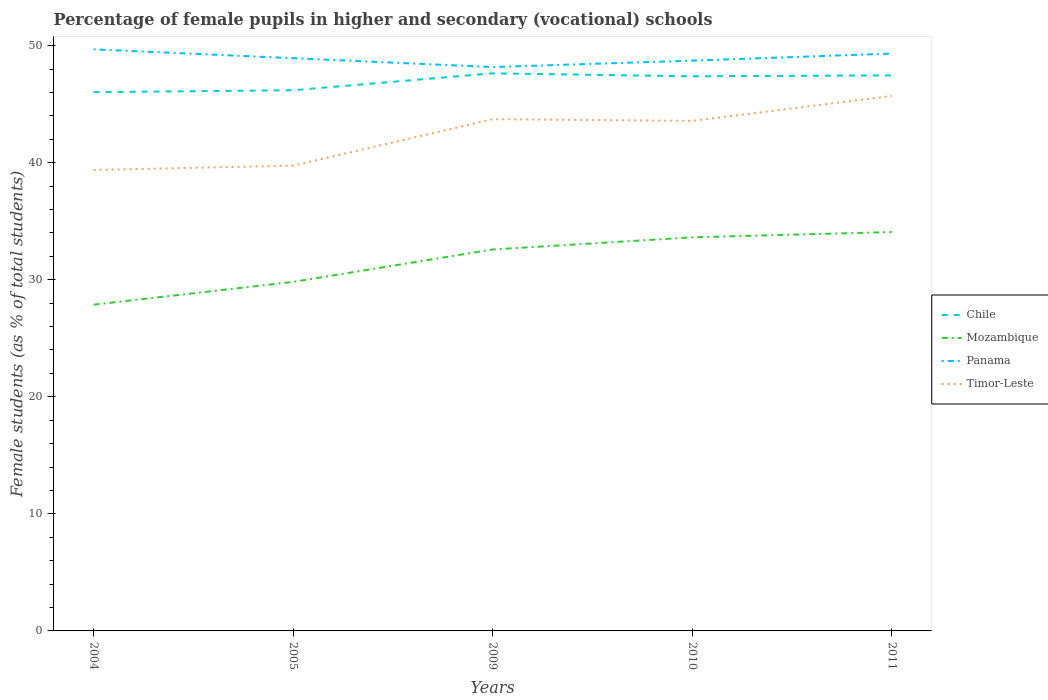How many different coloured lines are there?
Your answer should be compact. 4. Does the line corresponding to Timor-Leste intersect with the line corresponding to Chile?
Provide a short and direct response. No. Is the number of lines equal to the number of legend labels?
Ensure brevity in your answer.  Yes. Across all years, what is the maximum percentage of female pupils in higher and secondary schools in Mozambique?
Provide a succinct answer. 27.87. In which year was the percentage of female pupils in higher and secondary schools in Timor-Leste maximum?
Your answer should be very brief. 2004. What is the total percentage of female pupils in higher and secondary schools in Timor-Leste in the graph?
Keep it short and to the point. 0.15. What is the difference between the highest and the second highest percentage of female pupils in higher and secondary schools in Chile?
Provide a short and direct response. 1.61. What is the difference between the highest and the lowest percentage of female pupils in higher and secondary schools in Timor-Leste?
Provide a short and direct response. 3. Is the percentage of female pupils in higher and secondary schools in Chile strictly greater than the percentage of female pupils in higher and secondary schools in Panama over the years?
Keep it short and to the point. Yes. How many lines are there?
Ensure brevity in your answer.  4. What is the difference between two consecutive major ticks on the Y-axis?
Offer a terse response. 10. How many legend labels are there?
Your answer should be very brief. 4. How are the legend labels stacked?
Provide a succinct answer. Vertical. What is the title of the graph?
Offer a very short reply. Percentage of female pupils in higher and secondary (vocational) schools. What is the label or title of the X-axis?
Give a very brief answer. Years. What is the label or title of the Y-axis?
Your answer should be very brief. Female students (as % of total students). What is the Female students (as % of total students) in Chile in 2004?
Your answer should be compact. 46.03. What is the Female students (as % of total students) of Mozambique in 2004?
Your answer should be very brief. 27.87. What is the Female students (as % of total students) in Panama in 2004?
Your answer should be compact. 49.68. What is the Female students (as % of total students) of Timor-Leste in 2004?
Offer a very short reply. 39.38. What is the Female students (as % of total students) of Chile in 2005?
Keep it short and to the point. 46.19. What is the Female students (as % of total students) of Mozambique in 2005?
Your answer should be very brief. 29.82. What is the Female students (as % of total students) of Panama in 2005?
Provide a succinct answer. 48.93. What is the Female students (as % of total students) in Timor-Leste in 2005?
Your response must be concise. 39.75. What is the Female students (as % of total students) in Chile in 2009?
Your answer should be compact. 47.64. What is the Female students (as % of total students) in Mozambique in 2009?
Ensure brevity in your answer.  32.59. What is the Female students (as % of total students) of Panama in 2009?
Offer a very short reply. 48.17. What is the Female students (as % of total students) in Timor-Leste in 2009?
Your answer should be very brief. 43.72. What is the Female students (as % of total students) in Chile in 2010?
Make the answer very short. 47.38. What is the Female students (as % of total students) in Mozambique in 2010?
Provide a short and direct response. 33.62. What is the Female students (as % of total students) of Panama in 2010?
Offer a terse response. 48.72. What is the Female students (as % of total students) of Timor-Leste in 2010?
Your answer should be very brief. 43.57. What is the Female students (as % of total students) of Chile in 2011?
Ensure brevity in your answer.  47.46. What is the Female students (as % of total students) in Mozambique in 2011?
Offer a terse response. 34.08. What is the Female students (as % of total students) in Panama in 2011?
Your answer should be compact. 49.33. What is the Female students (as % of total students) in Timor-Leste in 2011?
Provide a short and direct response. 45.71. Across all years, what is the maximum Female students (as % of total students) in Chile?
Provide a short and direct response. 47.64. Across all years, what is the maximum Female students (as % of total students) in Mozambique?
Offer a very short reply. 34.08. Across all years, what is the maximum Female students (as % of total students) of Panama?
Your response must be concise. 49.68. Across all years, what is the maximum Female students (as % of total students) of Timor-Leste?
Your answer should be compact. 45.71. Across all years, what is the minimum Female students (as % of total students) in Chile?
Keep it short and to the point. 46.03. Across all years, what is the minimum Female students (as % of total students) of Mozambique?
Provide a succinct answer. 27.87. Across all years, what is the minimum Female students (as % of total students) in Panama?
Ensure brevity in your answer.  48.17. Across all years, what is the minimum Female students (as % of total students) in Timor-Leste?
Make the answer very short. 39.38. What is the total Female students (as % of total students) of Chile in the graph?
Keep it short and to the point. 234.7. What is the total Female students (as % of total students) of Mozambique in the graph?
Provide a succinct answer. 157.98. What is the total Female students (as % of total students) in Panama in the graph?
Offer a very short reply. 244.83. What is the total Female students (as % of total students) of Timor-Leste in the graph?
Offer a very short reply. 212.13. What is the difference between the Female students (as % of total students) of Chile in 2004 and that in 2005?
Your response must be concise. -0.17. What is the difference between the Female students (as % of total students) of Mozambique in 2004 and that in 2005?
Keep it short and to the point. -1.94. What is the difference between the Female students (as % of total students) in Panama in 2004 and that in 2005?
Keep it short and to the point. 0.76. What is the difference between the Female students (as % of total students) in Timor-Leste in 2004 and that in 2005?
Provide a succinct answer. -0.37. What is the difference between the Female students (as % of total students) of Chile in 2004 and that in 2009?
Ensure brevity in your answer.  -1.61. What is the difference between the Female students (as % of total students) of Mozambique in 2004 and that in 2009?
Your answer should be very brief. -4.71. What is the difference between the Female students (as % of total students) of Panama in 2004 and that in 2009?
Your answer should be very brief. 1.51. What is the difference between the Female students (as % of total students) in Timor-Leste in 2004 and that in 2009?
Provide a short and direct response. -4.34. What is the difference between the Female students (as % of total students) in Chile in 2004 and that in 2010?
Your answer should be compact. -1.35. What is the difference between the Female students (as % of total students) of Mozambique in 2004 and that in 2010?
Offer a very short reply. -5.75. What is the difference between the Female students (as % of total students) of Panama in 2004 and that in 2010?
Your response must be concise. 0.96. What is the difference between the Female students (as % of total students) in Timor-Leste in 2004 and that in 2010?
Keep it short and to the point. -4.2. What is the difference between the Female students (as % of total students) in Chile in 2004 and that in 2011?
Provide a succinct answer. -1.44. What is the difference between the Female students (as % of total students) of Mozambique in 2004 and that in 2011?
Your answer should be very brief. -6.2. What is the difference between the Female students (as % of total students) of Panama in 2004 and that in 2011?
Your answer should be very brief. 0.36. What is the difference between the Female students (as % of total students) of Timor-Leste in 2004 and that in 2011?
Ensure brevity in your answer.  -6.33. What is the difference between the Female students (as % of total students) of Chile in 2005 and that in 2009?
Your answer should be compact. -1.44. What is the difference between the Female students (as % of total students) of Mozambique in 2005 and that in 2009?
Offer a terse response. -2.77. What is the difference between the Female students (as % of total students) in Panama in 2005 and that in 2009?
Make the answer very short. 0.76. What is the difference between the Female students (as % of total students) of Timor-Leste in 2005 and that in 2009?
Give a very brief answer. -3.97. What is the difference between the Female students (as % of total students) of Chile in 2005 and that in 2010?
Offer a terse response. -1.19. What is the difference between the Female students (as % of total students) in Mozambique in 2005 and that in 2010?
Your response must be concise. -3.81. What is the difference between the Female students (as % of total students) of Panama in 2005 and that in 2010?
Your answer should be compact. 0.21. What is the difference between the Female students (as % of total students) in Timor-Leste in 2005 and that in 2010?
Your answer should be very brief. -3.82. What is the difference between the Female students (as % of total students) of Chile in 2005 and that in 2011?
Offer a very short reply. -1.27. What is the difference between the Female students (as % of total students) in Mozambique in 2005 and that in 2011?
Keep it short and to the point. -4.26. What is the difference between the Female students (as % of total students) of Panama in 2005 and that in 2011?
Offer a very short reply. -0.4. What is the difference between the Female students (as % of total students) in Timor-Leste in 2005 and that in 2011?
Keep it short and to the point. -5.96. What is the difference between the Female students (as % of total students) in Chile in 2009 and that in 2010?
Make the answer very short. 0.26. What is the difference between the Female students (as % of total students) of Mozambique in 2009 and that in 2010?
Offer a terse response. -1.04. What is the difference between the Female students (as % of total students) in Panama in 2009 and that in 2010?
Keep it short and to the point. -0.55. What is the difference between the Female students (as % of total students) in Timor-Leste in 2009 and that in 2010?
Offer a very short reply. 0.14. What is the difference between the Female students (as % of total students) in Chile in 2009 and that in 2011?
Ensure brevity in your answer.  0.17. What is the difference between the Female students (as % of total students) in Mozambique in 2009 and that in 2011?
Your response must be concise. -1.49. What is the difference between the Female students (as % of total students) of Panama in 2009 and that in 2011?
Your answer should be compact. -1.15. What is the difference between the Female students (as % of total students) of Timor-Leste in 2009 and that in 2011?
Ensure brevity in your answer.  -1.99. What is the difference between the Female students (as % of total students) in Chile in 2010 and that in 2011?
Give a very brief answer. -0.08. What is the difference between the Female students (as % of total students) in Mozambique in 2010 and that in 2011?
Keep it short and to the point. -0.45. What is the difference between the Female students (as % of total students) of Panama in 2010 and that in 2011?
Provide a succinct answer. -0.6. What is the difference between the Female students (as % of total students) of Timor-Leste in 2010 and that in 2011?
Keep it short and to the point. -2.13. What is the difference between the Female students (as % of total students) in Chile in 2004 and the Female students (as % of total students) in Mozambique in 2005?
Your answer should be compact. 16.21. What is the difference between the Female students (as % of total students) in Chile in 2004 and the Female students (as % of total students) in Panama in 2005?
Provide a short and direct response. -2.9. What is the difference between the Female students (as % of total students) in Chile in 2004 and the Female students (as % of total students) in Timor-Leste in 2005?
Keep it short and to the point. 6.28. What is the difference between the Female students (as % of total students) of Mozambique in 2004 and the Female students (as % of total students) of Panama in 2005?
Your response must be concise. -21.05. What is the difference between the Female students (as % of total students) in Mozambique in 2004 and the Female students (as % of total students) in Timor-Leste in 2005?
Your response must be concise. -11.88. What is the difference between the Female students (as % of total students) of Panama in 2004 and the Female students (as % of total students) of Timor-Leste in 2005?
Provide a short and direct response. 9.94. What is the difference between the Female students (as % of total students) in Chile in 2004 and the Female students (as % of total students) in Mozambique in 2009?
Offer a terse response. 13.44. What is the difference between the Female students (as % of total students) of Chile in 2004 and the Female students (as % of total students) of Panama in 2009?
Make the answer very short. -2.14. What is the difference between the Female students (as % of total students) in Chile in 2004 and the Female students (as % of total students) in Timor-Leste in 2009?
Your response must be concise. 2.31. What is the difference between the Female students (as % of total students) of Mozambique in 2004 and the Female students (as % of total students) of Panama in 2009?
Make the answer very short. -20.3. What is the difference between the Female students (as % of total students) in Mozambique in 2004 and the Female students (as % of total students) in Timor-Leste in 2009?
Offer a very short reply. -15.85. What is the difference between the Female students (as % of total students) of Panama in 2004 and the Female students (as % of total students) of Timor-Leste in 2009?
Offer a very short reply. 5.97. What is the difference between the Female students (as % of total students) in Chile in 2004 and the Female students (as % of total students) in Mozambique in 2010?
Provide a succinct answer. 12.4. What is the difference between the Female students (as % of total students) in Chile in 2004 and the Female students (as % of total students) in Panama in 2010?
Give a very brief answer. -2.69. What is the difference between the Female students (as % of total students) in Chile in 2004 and the Female students (as % of total students) in Timor-Leste in 2010?
Your response must be concise. 2.45. What is the difference between the Female students (as % of total students) of Mozambique in 2004 and the Female students (as % of total students) of Panama in 2010?
Keep it short and to the point. -20.85. What is the difference between the Female students (as % of total students) in Mozambique in 2004 and the Female students (as % of total students) in Timor-Leste in 2010?
Your answer should be very brief. -15.7. What is the difference between the Female students (as % of total students) in Panama in 2004 and the Female students (as % of total students) in Timor-Leste in 2010?
Your answer should be very brief. 6.11. What is the difference between the Female students (as % of total students) in Chile in 2004 and the Female students (as % of total students) in Mozambique in 2011?
Offer a very short reply. 11.95. What is the difference between the Female students (as % of total students) in Chile in 2004 and the Female students (as % of total students) in Panama in 2011?
Offer a terse response. -3.3. What is the difference between the Female students (as % of total students) of Chile in 2004 and the Female students (as % of total students) of Timor-Leste in 2011?
Your answer should be very brief. 0.32. What is the difference between the Female students (as % of total students) of Mozambique in 2004 and the Female students (as % of total students) of Panama in 2011?
Provide a short and direct response. -21.45. What is the difference between the Female students (as % of total students) of Mozambique in 2004 and the Female students (as % of total students) of Timor-Leste in 2011?
Your response must be concise. -17.83. What is the difference between the Female students (as % of total students) in Panama in 2004 and the Female students (as % of total students) in Timor-Leste in 2011?
Provide a succinct answer. 3.98. What is the difference between the Female students (as % of total students) in Chile in 2005 and the Female students (as % of total students) in Mozambique in 2009?
Give a very brief answer. 13.61. What is the difference between the Female students (as % of total students) of Chile in 2005 and the Female students (as % of total students) of Panama in 2009?
Your answer should be compact. -1.98. What is the difference between the Female students (as % of total students) of Chile in 2005 and the Female students (as % of total students) of Timor-Leste in 2009?
Offer a very short reply. 2.47. What is the difference between the Female students (as % of total students) in Mozambique in 2005 and the Female students (as % of total students) in Panama in 2009?
Ensure brevity in your answer.  -18.35. What is the difference between the Female students (as % of total students) of Mozambique in 2005 and the Female students (as % of total students) of Timor-Leste in 2009?
Offer a very short reply. -13.9. What is the difference between the Female students (as % of total students) in Panama in 2005 and the Female students (as % of total students) in Timor-Leste in 2009?
Your answer should be very brief. 5.21. What is the difference between the Female students (as % of total students) in Chile in 2005 and the Female students (as % of total students) in Mozambique in 2010?
Provide a short and direct response. 12.57. What is the difference between the Female students (as % of total students) of Chile in 2005 and the Female students (as % of total students) of Panama in 2010?
Make the answer very short. -2.53. What is the difference between the Female students (as % of total students) in Chile in 2005 and the Female students (as % of total students) in Timor-Leste in 2010?
Your answer should be very brief. 2.62. What is the difference between the Female students (as % of total students) of Mozambique in 2005 and the Female students (as % of total students) of Panama in 2010?
Keep it short and to the point. -18.9. What is the difference between the Female students (as % of total students) in Mozambique in 2005 and the Female students (as % of total students) in Timor-Leste in 2010?
Provide a succinct answer. -13.76. What is the difference between the Female students (as % of total students) in Panama in 2005 and the Female students (as % of total students) in Timor-Leste in 2010?
Your answer should be compact. 5.35. What is the difference between the Female students (as % of total students) in Chile in 2005 and the Female students (as % of total students) in Mozambique in 2011?
Make the answer very short. 12.12. What is the difference between the Female students (as % of total students) of Chile in 2005 and the Female students (as % of total students) of Panama in 2011?
Your response must be concise. -3.13. What is the difference between the Female students (as % of total students) of Chile in 2005 and the Female students (as % of total students) of Timor-Leste in 2011?
Provide a succinct answer. 0.49. What is the difference between the Female students (as % of total students) of Mozambique in 2005 and the Female students (as % of total students) of Panama in 2011?
Ensure brevity in your answer.  -19.51. What is the difference between the Female students (as % of total students) of Mozambique in 2005 and the Female students (as % of total students) of Timor-Leste in 2011?
Make the answer very short. -15.89. What is the difference between the Female students (as % of total students) of Panama in 2005 and the Female students (as % of total students) of Timor-Leste in 2011?
Your answer should be very brief. 3.22. What is the difference between the Female students (as % of total students) of Chile in 2009 and the Female students (as % of total students) of Mozambique in 2010?
Offer a terse response. 14.01. What is the difference between the Female students (as % of total students) in Chile in 2009 and the Female students (as % of total students) in Panama in 2010?
Provide a succinct answer. -1.08. What is the difference between the Female students (as % of total students) in Chile in 2009 and the Female students (as % of total students) in Timor-Leste in 2010?
Your answer should be very brief. 4.06. What is the difference between the Female students (as % of total students) in Mozambique in 2009 and the Female students (as % of total students) in Panama in 2010?
Make the answer very short. -16.13. What is the difference between the Female students (as % of total students) of Mozambique in 2009 and the Female students (as % of total students) of Timor-Leste in 2010?
Make the answer very short. -10.99. What is the difference between the Female students (as % of total students) in Panama in 2009 and the Female students (as % of total students) in Timor-Leste in 2010?
Provide a short and direct response. 4.6. What is the difference between the Female students (as % of total students) of Chile in 2009 and the Female students (as % of total students) of Mozambique in 2011?
Offer a very short reply. 13.56. What is the difference between the Female students (as % of total students) of Chile in 2009 and the Female students (as % of total students) of Panama in 2011?
Provide a succinct answer. -1.69. What is the difference between the Female students (as % of total students) in Chile in 2009 and the Female students (as % of total students) in Timor-Leste in 2011?
Offer a terse response. 1.93. What is the difference between the Female students (as % of total students) in Mozambique in 2009 and the Female students (as % of total students) in Panama in 2011?
Ensure brevity in your answer.  -16.74. What is the difference between the Female students (as % of total students) of Mozambique in 2009 and the Female students (as % of total students) of Timor-Leste in 2011?
Provide a succinct answer. -13.12. What is the difference between the Female students (as % of total students) in Panama in 2009 and the Female students (as % of total students) in Timor-Leste in 2011?
Give a very brief answer. 2.46. What is the difference between the Female students (as % of total students) of Chile in 2010 and the Female students (as % of total students) of Mozambique in 2011?
Provide a succinct answer. 13.3. What is the difference between the Female students (as % of total students) of Chile in 2010 and the Female students (as % of total students) of Panama in 2011?
Give a very brief answer. -1.95. What is the difference between the Female students (as % of total students) in Chile in 2010 and the Female students (as % of total students) in Timor-Leste in 2011?
Give a very brief answer. 1.67. What is the difference between the Female students (as % of total students) in Mozambique in 2010 and the Female students (as % of total students) in Panama in 2011?
Your answer should be very brief. -15.7. What is the difference between the Female students (as % of total students) in Mozambique in 2010 and the Female students (as % of total students) in Timor-Leste in 2011?
Provide a succinct answer. -12.08. What is the difference between the Female students (as % of total students) of Panama in 2010 and the Female students (as % of total students) of Timor-Leste in 2011?
Ensure brevity in your answer.  3.01. What is the average Female students (as % of total students) in Chile per year?
Ensure brevity in your answer.  46.94. What is the average Female students (as % of total students) in Mozambique per year?
Ensure brevity in your answer.  31.6. What is the average Female students (as % of total students) of Panama per year?
Offer a terse response. 48.97. What is the average Female students (as % of total students) of Timor-Leste per year?
Provide a short and direct response. 42.43. In the year 2004, what is the difference between the Female students (as % of total students) of Chile and Female students (as % of total students) of Mozambique?
Give a very brief answer. 18.15. In the year 2004, what is the difference between the Female students (as % of total students) of Chile and Female students (as % of total students) of Panama?
Ensure brevity in your answer.  -3.66. In the year 2004, what is the difference between the Female students (as % of total students) in Chile and Female students (as % of total students) in Timor-Leste?
Make the answer very short. 6.65. In the year 2004, what is the difference between the Female students (as % of total students) in Mozambique and Female students (as % of total students) in Panama?
Your answer should be very brief. -21.81. In the year 2004, what is the difference between the Female students (as % of total students) of Mozambique and Female students (as % of total students) of Timor-Leste?
Your answer should be very brief. -11.51. In the year 2004, what is the difference between the Female students (as % of total students) in Panama and Female students (as % of total students) in Timor-Leste?
Make the answer very short. 10.31. In the year 2005, what is the difference between the Female students (as % of total students) in Chile and Female students (as % of total students) in Mozambique?
Provide a succinct answer. 16.37. In the year 2005, what is the difference between the Female students (as % of total students) in Chile and Female students (as % of total students) in Panama?
Ensure brevity in your answer.  -2.74. In the year 2005, what is the difference between the Female students (as % of total students) in Chile and Female students (as % of total students) in Timor-Leste?
Provide a succinct answer. 6.44. In the year 2005, what is the difference between the Female students (as % of total students) in Mozambique and Female students (as % of total students) in Panama?
Provide a succinct answer. -19.11. In the year 2005, what is the difference between the Female students (as % of total students) in Mozambique and Female students (as % of total students) in Timor-Leste?
Offer a terse response. -9.93. In the year 2005, what is the difference between the Female students (as % of total students) in Panama and Female students (as % of total students) in Timor-Leste?
Offer a terse response. 9.18. In the year 2009, what is the difference between the Female students (as % of total students) of Chile and Female students (as % of total students) of Mozambique?
Your answer should be compact. 15.05. In the year 2009, what is the difference between the Female students (as % of total students) of Chile and Female students (as % of total students) of Panama?
Offer a very short reply. -0.53. In the year 2009, what is the difference between the Female students (as % of total students) in Chile and Female students (as % of total students) in Timor-Leste?
Provide a succinct answer. 3.92. In the year 2009, what is the difference between the Female students (as % of total students) of Mozambique and Female students (as % of total students) of Panama?
Offer a terse response. -15.58. In the year 2009, what is the difference between the Female students (as % of total students) of Mozambique and Female students (as % of total students) of Timor-Leste?
Your answer should be very brief. -11.13. In the year 2009, what is the difference between the Female students (as % of total students) in Panama and Female students (as % of total students) in Timor-Leste?
Provide a succinct answer. 4.45. In the year 2010, what is the difference between the Female students (as % of total students) of Chile and Female students (as % of total students) of Mozambique?
Provide a short and direct response. 13.75. In the year 2010, what is the difference between the Female students (as % of total students) in Chile and Female students (as % of total students) in Panama?
Offer a terse response. -1.34. In the year 2010, what is the difference between the Female students (as % of total students) in Chile and Female students (as % of total students) in Timor-Leste?
Ensure brevity in your answer.  3.81. In the year 2010, what is the difference between the Female students (as % of total students) in Mozambique and Female students (as % of total students) in Panama?
Give a very brief answer. -15.1. In the year 2010, what is the difference between the Female students (as % of total students) of Mozambique and Female students (as % of total students) of Timor-Leste?
Offer a very short reply. -9.95. In the year 2010, what is the difference between the Female students (as % of total students) of Panama and Female students (as % of total students) of Timor-Leste?
Ensure brevity in your answer.  5.15. In the year 2011, what is the difference between the Female students (as % of total students) in Chile and Female students (as % of total students) in Mozambique?
Offer a very short reply. 13.39. In the year 2011, what is the difference between the Female students (as % of total students) in Chile and Female students (as % of total students) in Panama?
Ensure brevity in your answer.  -1.86. In the year 2011, what is the difference between the Female students (as % of total students) in Chile and Female students (as % of total students) in Timor-Leste?
Ensure brevity in your answer.  1.76. In the year 2011, what is the difference between the Female students (as % of total students) of Mozambique and Female students (as % of total students) of Panama?
Make the answer very short. -15.25. In the year 2011, what is the difference between the Female students (as % of total students) in Mozambique and Female students (as % of total students) in Timor-Leste?
Keep it short and to the point. -11.63. In the year 2011, what is the difference between the Female students (as % of total students) of Panama and Female students (as % of total students) of Timor-Leste?
Offer a very short reply. 3.62. What is the ratio of the Female students (as % of total students) in Mozambique in 2004 to that in 2005?
Provide a succinct answer. 0.93. What is the ratio of the Female students (as % of total students) of Panama in 2004 to that in 2005?
Give a very brief answer. 1.02. What is the ratio of the Female students (as % of total students) of Chile in 2004 to that in 2009?
Your response must be concise. 0.97. What is the ratio of the Female students (as % of total students) of Mozambique in 2004 to that in 2009?
Make the answer very short. 0.86. What is the ratio of the Female students (as % of total students) in Panama in 2004 to that in 2009?
Offer a terse response. 1.03. What is the ratio of the Female students (as % of total students) in Timor-Leste in 2004 to that in 2009?
Provide a short and direct response. 0.9. What is the ratio of the Female students (as % of total students) of Chile in 2004 to that in 2010?
Your answer should be very brief. 0.97. What is the ratio of the Female students (as % of total students) in Mozambique in 2004 to that in 2010?
Give a very brief answer. 0.83. What is the ratio of the Female students (as % of total students) in Panama in 2004 to that in 2010?
Make the answer very short. 1.02. What is the ratio of the Female students (as % of total students) of Timor-Leste in 2004 to that in 2010?
Ensure brevity in your answer.  0.9. What is the ratio of the Female students (as % of total students) in Chile in 2004 to that in 2011?
Provide a succinct answer. 0.97. What is the ratio of the Female students (as % of total students) in Mozambique in 2004 to that in 2011?
Give a very brief answer. 0.82. What is the ratio of the Female students (as % of total students) in Panama in 2004 to that in 2011?
Give a very brief answer. 1.01. What is the ratio of the Female students (as % of total students) in Timor-Leste in 2004 to that in 2011?
Make the answer very short. 0.86. What is the ratio of the Female students (as % of total students) of Chile in 2005 to that in 2009?
Provide a short and direct response. 0.97. What is the ratio of the Female students (as % of total students) of Mozambique in 2005 to that in 2009?
Your answer should be very brief. 0.92. What is the ratio of the Female students (as % of total students) of Panama in 2005 to that in 2009?
Your answer should be very brief. 1.02. What is the ratio of the Female students (as % of total students) of Timor-Leste in 2005 to that in 2009?
Make the answer very short. 0.91. What is the ratio of the Female students (as % of total students) of Chile in 2005 to that in 2010?
Keep it short and to the point. 0.97. What is the ratio of the Female students (as % of total students) of Mozambique in 2005 to that in 2010?
Your answer should be very brief. 0.89. What is the ratio of the Female students (as % of total students) in Panama in 2005 to that in 2010?
Your answer should be compact. 1. What is the ratio of the Female students (as % of total students) in Timor-Leste in 2005 to that in 2010?
Your response must be concise. 0.91. What is the ratio of the Female students (as % of total students) in Chile in 2005 to that in 2011?
Your answer should be compact. 0.97. What is the ratio of the Female students (as % of total students) of Mozambique in 2005 to that in 2011?
Your answer should be very brief. 0.88. What is the ratio of the Female students (as % of total students) of Timor-Leste in 2005 to that in 2011?
Your answer should be compact. 0.87. What is the ratio of the Female students (as % of total students) in Chile in 2009 to that in 2010?
Provide a short and direct response. 1.01. What is the ratio of the Female students (as % of total students) of Mozambique in 2009 to that in 2010?
Your answer should be very brief. 0.97. What is the ratio of the Female students (as % of total students) in Panama in 2009 to that in 2010?
Give a very brief answer. 0.99. What is the ratio of the Female students (as % of total students) in Chile in 2009 to that in 2011?
Your response must be concise. 1. What is the ratio of the Female students (as % of total students) of Mozambique in 2009 to that in 2011?
Provide a succinct answer. 0.96. What is the ratio of the Female students (as % of total students) of Panama in 2009 to that in 2011?
Give a very brief answer. 0.98. What is the ratio of the Female students (as % of total students) of Timor-Leste in 2009 to that in 2011?
Offer a very short reply. 0.96. What is the ratio of the Female students (as % of total students) in Chile in 2010 to that in 2011?
Offer a very short reply. 1. What is the ratio of the Female students (as % of total students) of Mozambique in 2010 to that in 2011?
Offer a terse response. 0.99. What is the ratio of the Female students (as % of total students) in Timor-Leste in 2010 to that in 2011?
Ensure brevity in your answer.  0.95. What is the difference between the highest and the second highest Female students (as % of total students) in Chile?
Keep it short and to the point. 0.17. What is the difference between the highest and the second highest Female students (as % of total students) of Mozambique?
Your answer should be very brief. 0.45. What is the difference between the highest and the second highest Female students (as % of total students) of Panama?
Offer a terse response. 0.36. What is the difference between the highest and the second highest Female students (as % of total students) in Timor-Leste?
Your answer should be very brief. 1.99. What is the difference between the highest and the lowest Female students (as % of total students) in Chile?
Ensure brevity in your answer.  1.61. What is the difference between the highest and the lowest Female students (as % of total students) of Mozambique?
Provide a succinct answer. 6.2. What is the difference between the highest and the lowest Female students (as % of total students) in Panama?
Provide a short and direct response. 1.51. What is the difference between the highest and the lowest Female students (as % of total students) in Timor-Leste?
Provide a succinct answer. 6.33. 